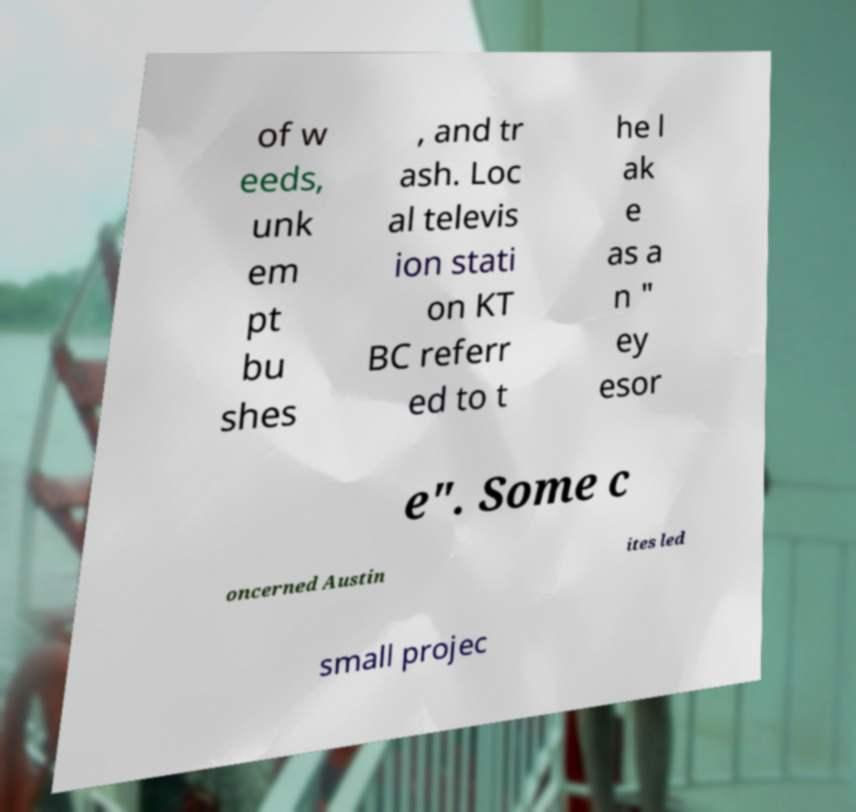I need the written content from this picture converted into text. Can you do that? of w eeds, unk em pt bu shes , and tr ash. Loc al televis ion stati on KT BC referr ed to t he l ak e as a n " ey esor e". Some c oncerned Austin ites led small projec 